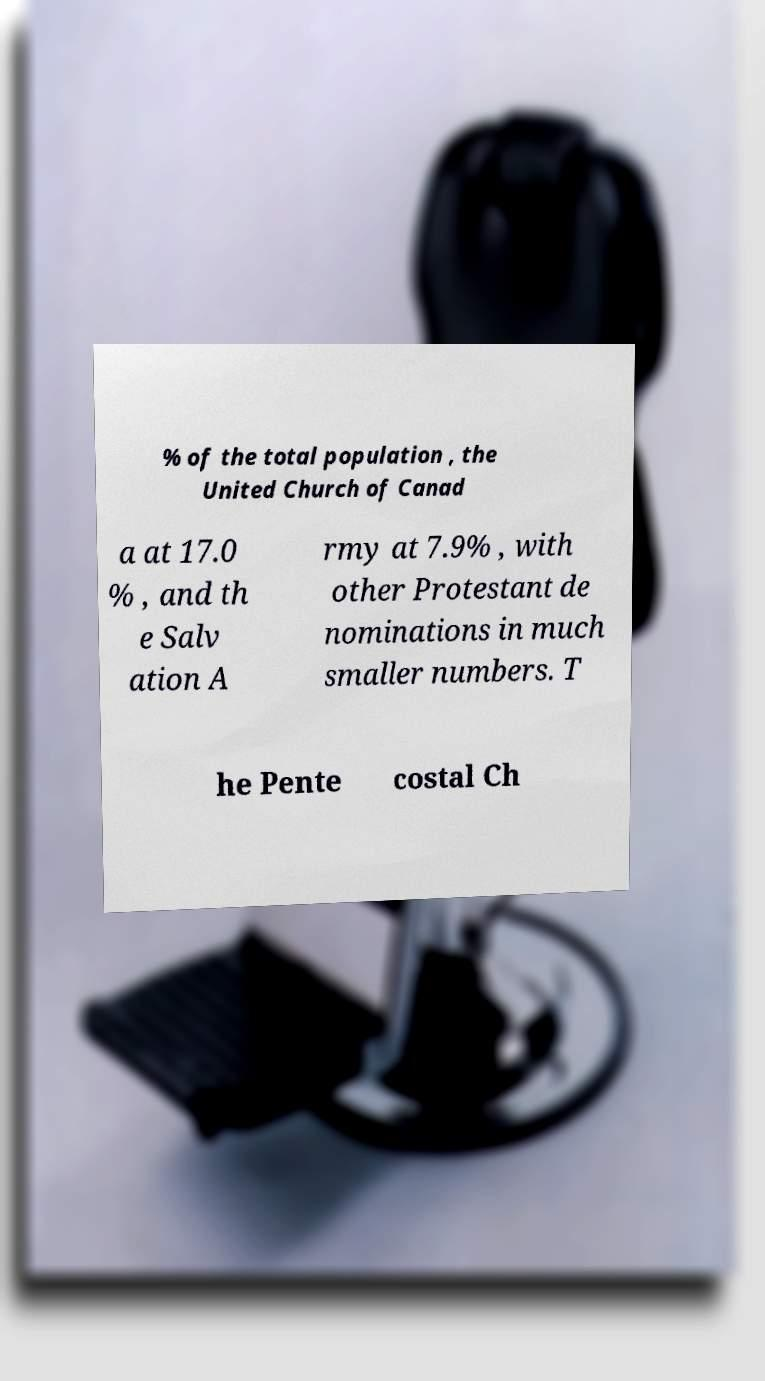Could you extract and type out the text from this image? % of the total population , the United Church of Canad a at 17.0 % , and th e Salv ation A rmy at 7.9% , with other Protestant de nominations in much smaller numbers. T he Pente costal Ch 